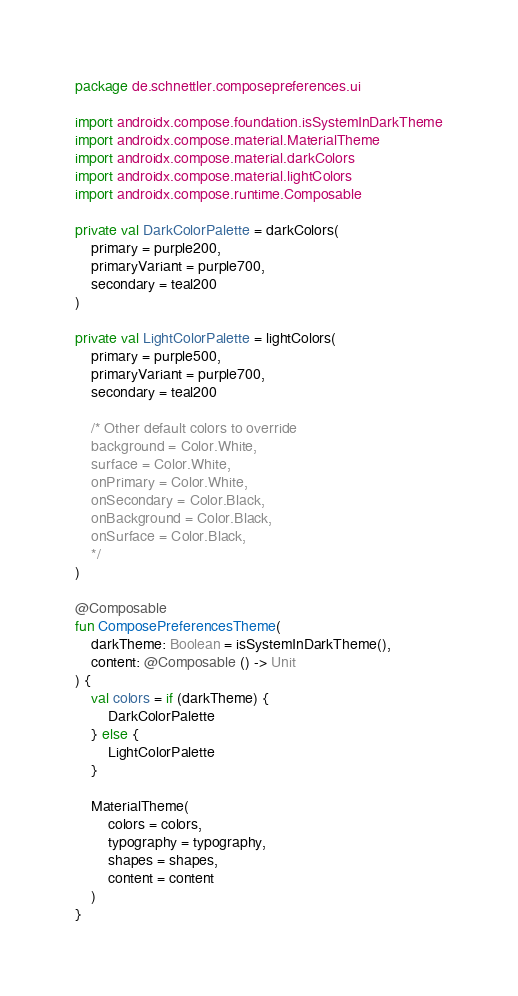<code> <loc_0><loc_0><loc_500><loc_500><_Kotlin_>package de.schnettler.composepreferences.ui

import androidx.compose.foundation.isSystemInDarkTheme
import androidx.compose.material.MaterialTheme
import androidx.compose.material.darkColors
import androidx.compose.material.lightColors
import androidx.compose.runtime.Composable

private val DarkColorPalette = darkColors(
    primary = purple200,
    primaryVariant = purple700,
    secondary = teal200
)

private val LightColorPalette = lightColors(
    primary = purple500,
    primaryVariant = purple700,
    secondary = teal200

    /* Other default colors to override
    background = Color.White,
    surface = Color.White,
    onPrimary = Color.White,
    onSecondary = Color.Black,
    onBackground = Color.Black,
    onSurface = Color.Black,
    */
)

@Composable
fun ComposePreferencesTheme(
    darkTheme: Boolean = isSystemInDarkTheme(),
    content: @Composable () -> Unit
) {
    val colors = if (darkTheme) {
        DarkColorPalette
    } else {
        LightColorPalette
    }

    MaterialTheme(
        colors = colors,
        typography = typography,
        shapes = shapes,
        content = content
    )
}</code> 